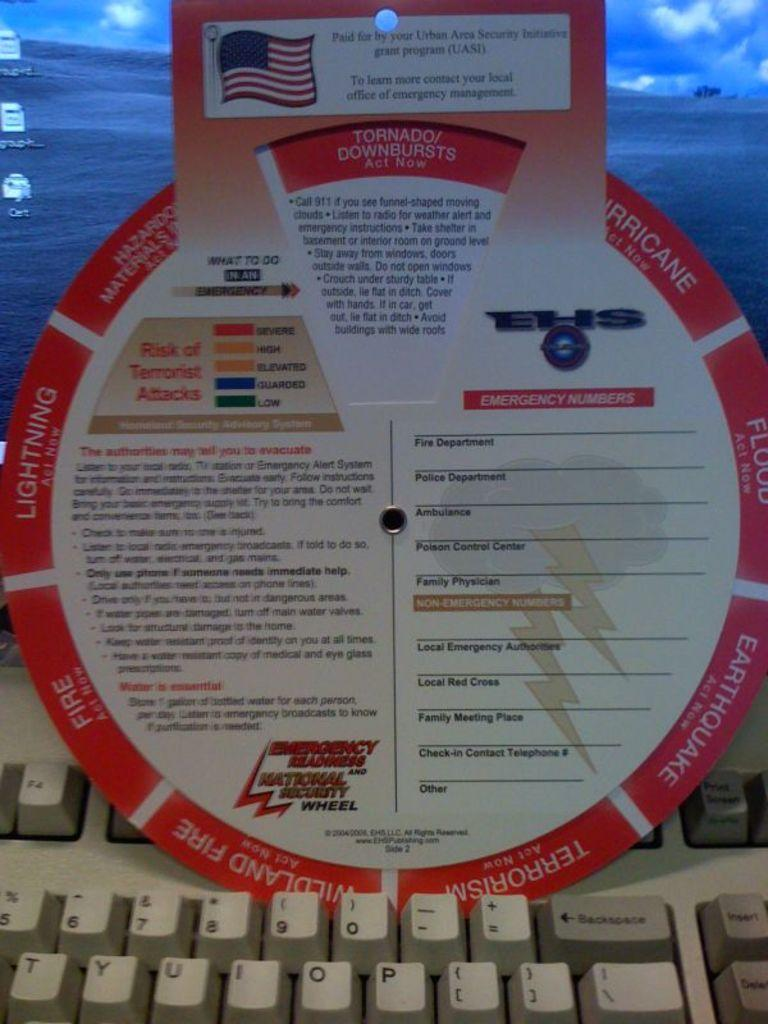<image>
Share a concise interpretation of the image provided. Emergency readiness and national security wheel sitting on a keyboard. 